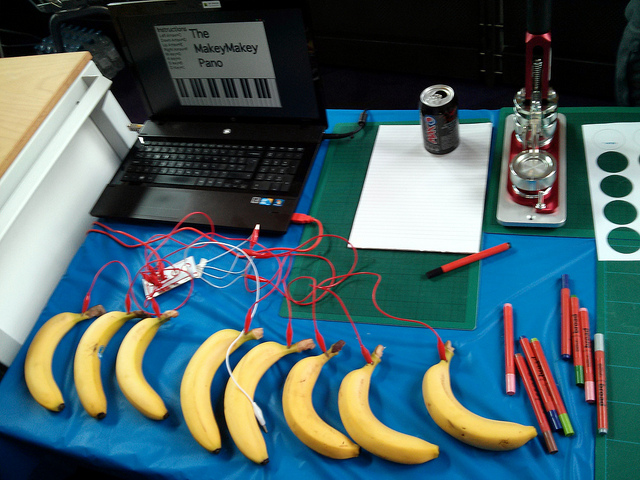<image>What are these objects used for? I don't know. These objects might be used for an app, food, electrodes, eating, science experiment, experiment, testing or eating. What are these objects used for? It is not clear what these objects are used for. They can be used for various purposes. 